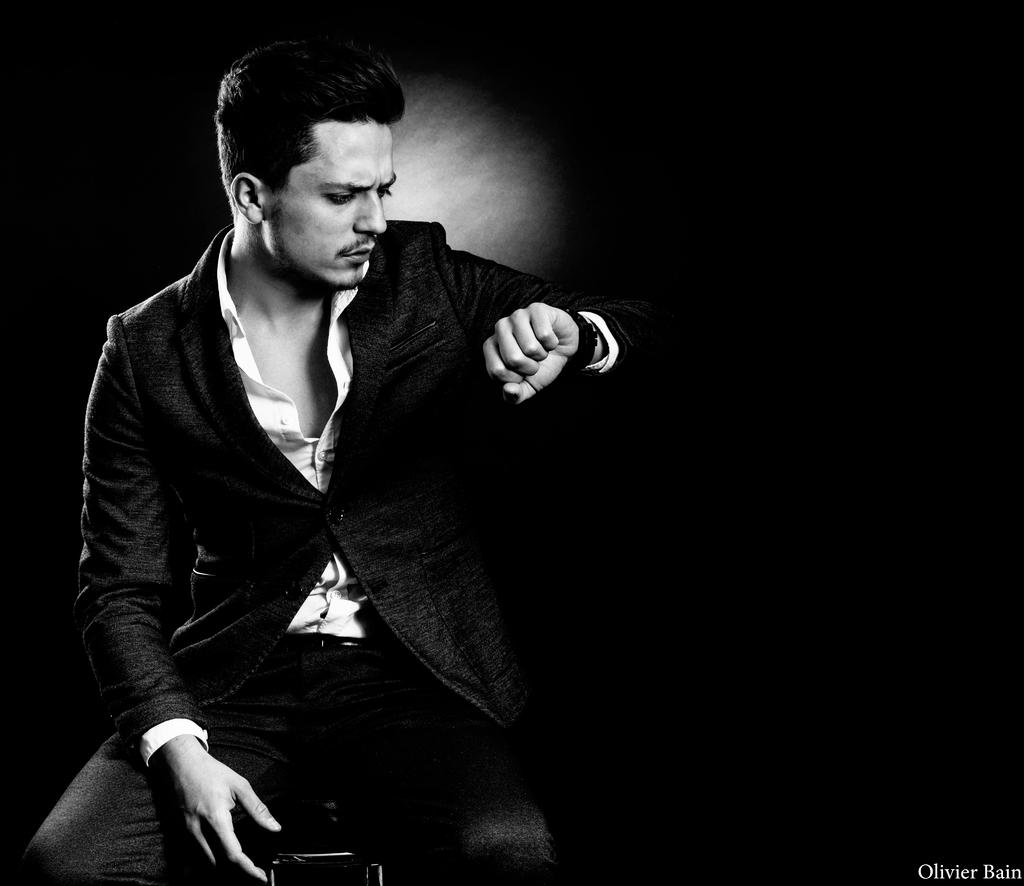What is the color scheme of the image? The image is black and white. What is the man in the image doing? The man is sitting on a table in the image. Is there any text present in the image? Yes, there is some text in the bottom right corner of the image. How would you describe the overall lighting or brightness of the image? The background of the image is dark. How many clover leaves can be seen in the image? There are no clover leaves present in the image. What type of tool is the man using in the image? The image does not show the man using any tool, such as a wrench. 